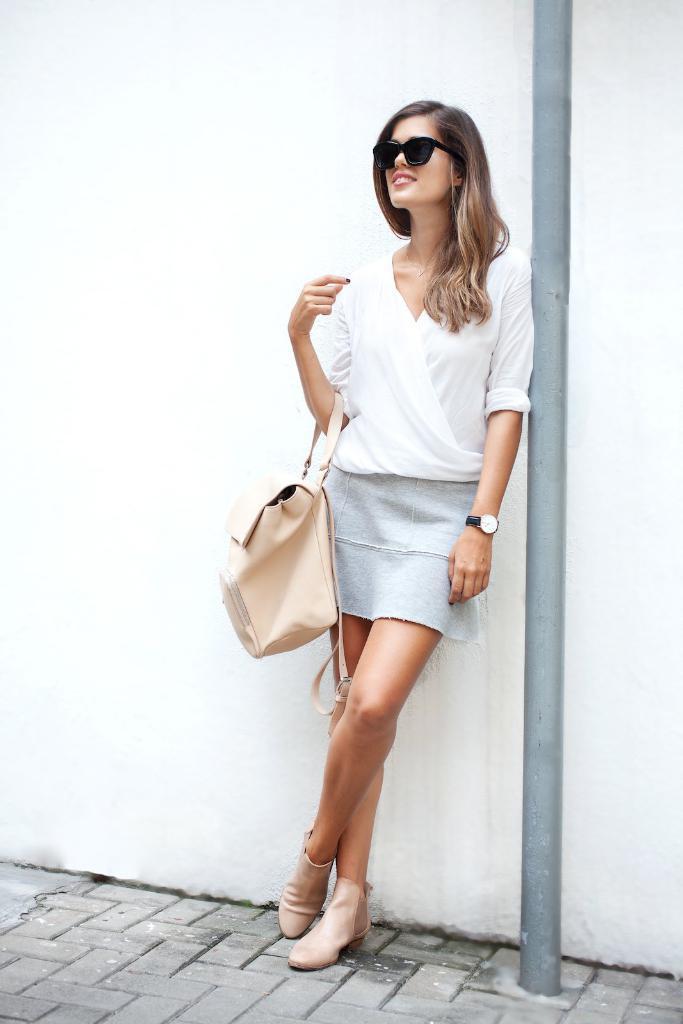Please provide a concise description of this image. In this picture we can see a woman. She is leaning on to the wall. She has spectacles and she is carrying a bag. And this is pole. 